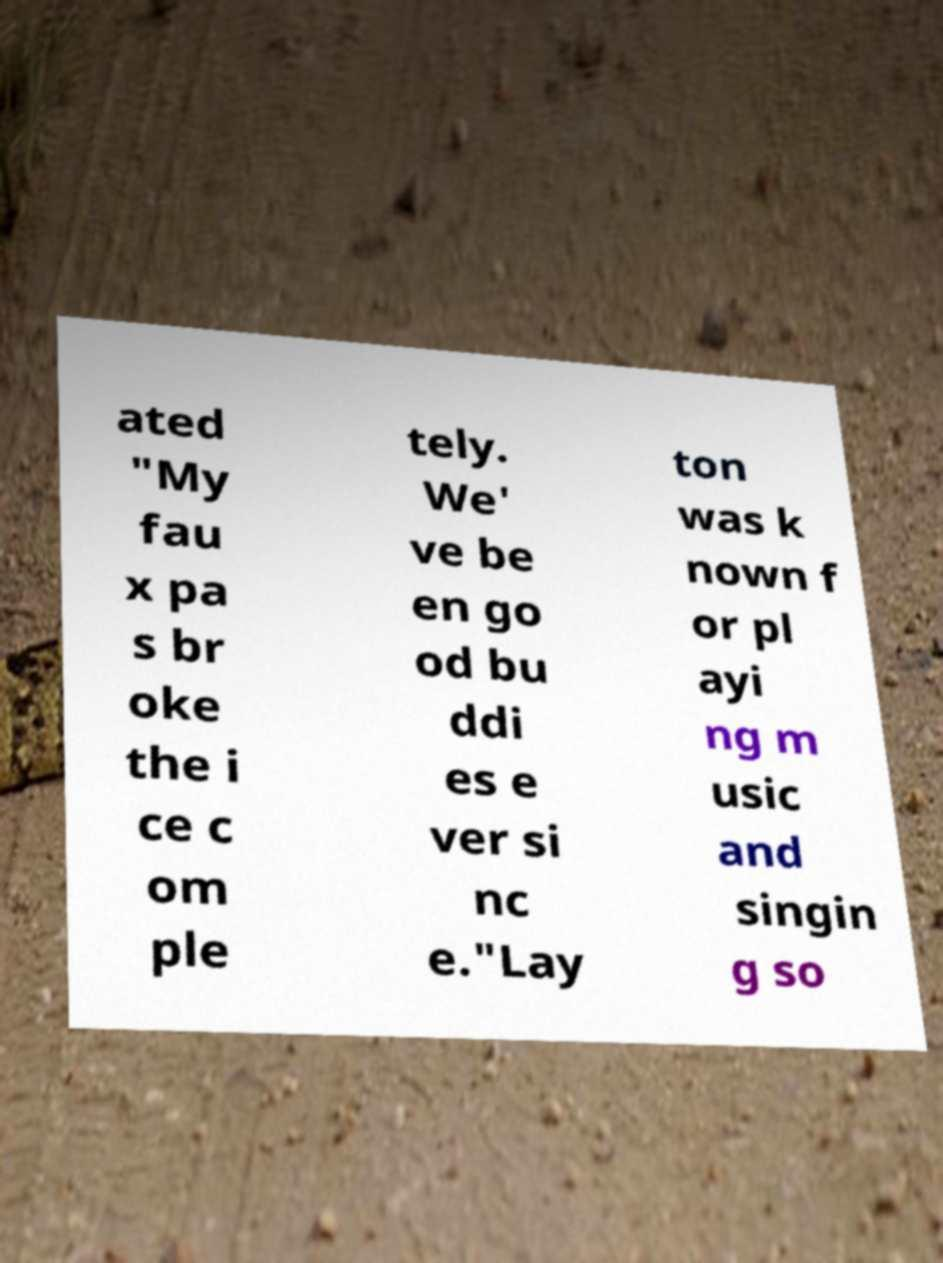Can you read and provide the text displayed in the image?This photo seems to have some interesting text. Can you extract and type it out for me? ated "My fau x pa s br oke the i ce c om ple tely. We' ve be en go od bu ddi es e ver si nc e."Lay ton was k nown f or pl ayi ng m usic and singin g so 